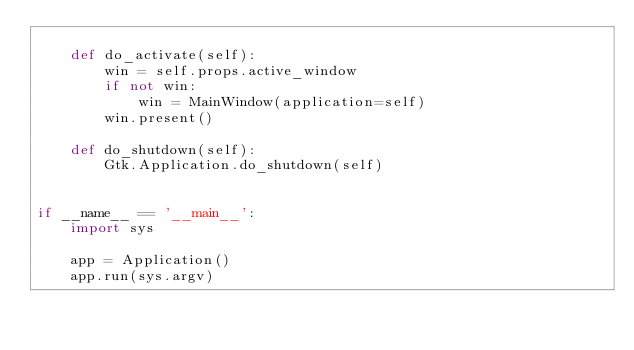<code> <loc_0><loc_0><loc_500><loc_500><_Python_>
    def do_activate(self):
        win = self.props.active_window
        if not win:
            win = MainWindow(application=self)
        win.present()

    def do_shutdown(self):
        Gtk.Application.do_shutdown(self)


if __name__ == '__main__':
    import sys

    app = Application()
    app.run(sys.argv)
</code> 